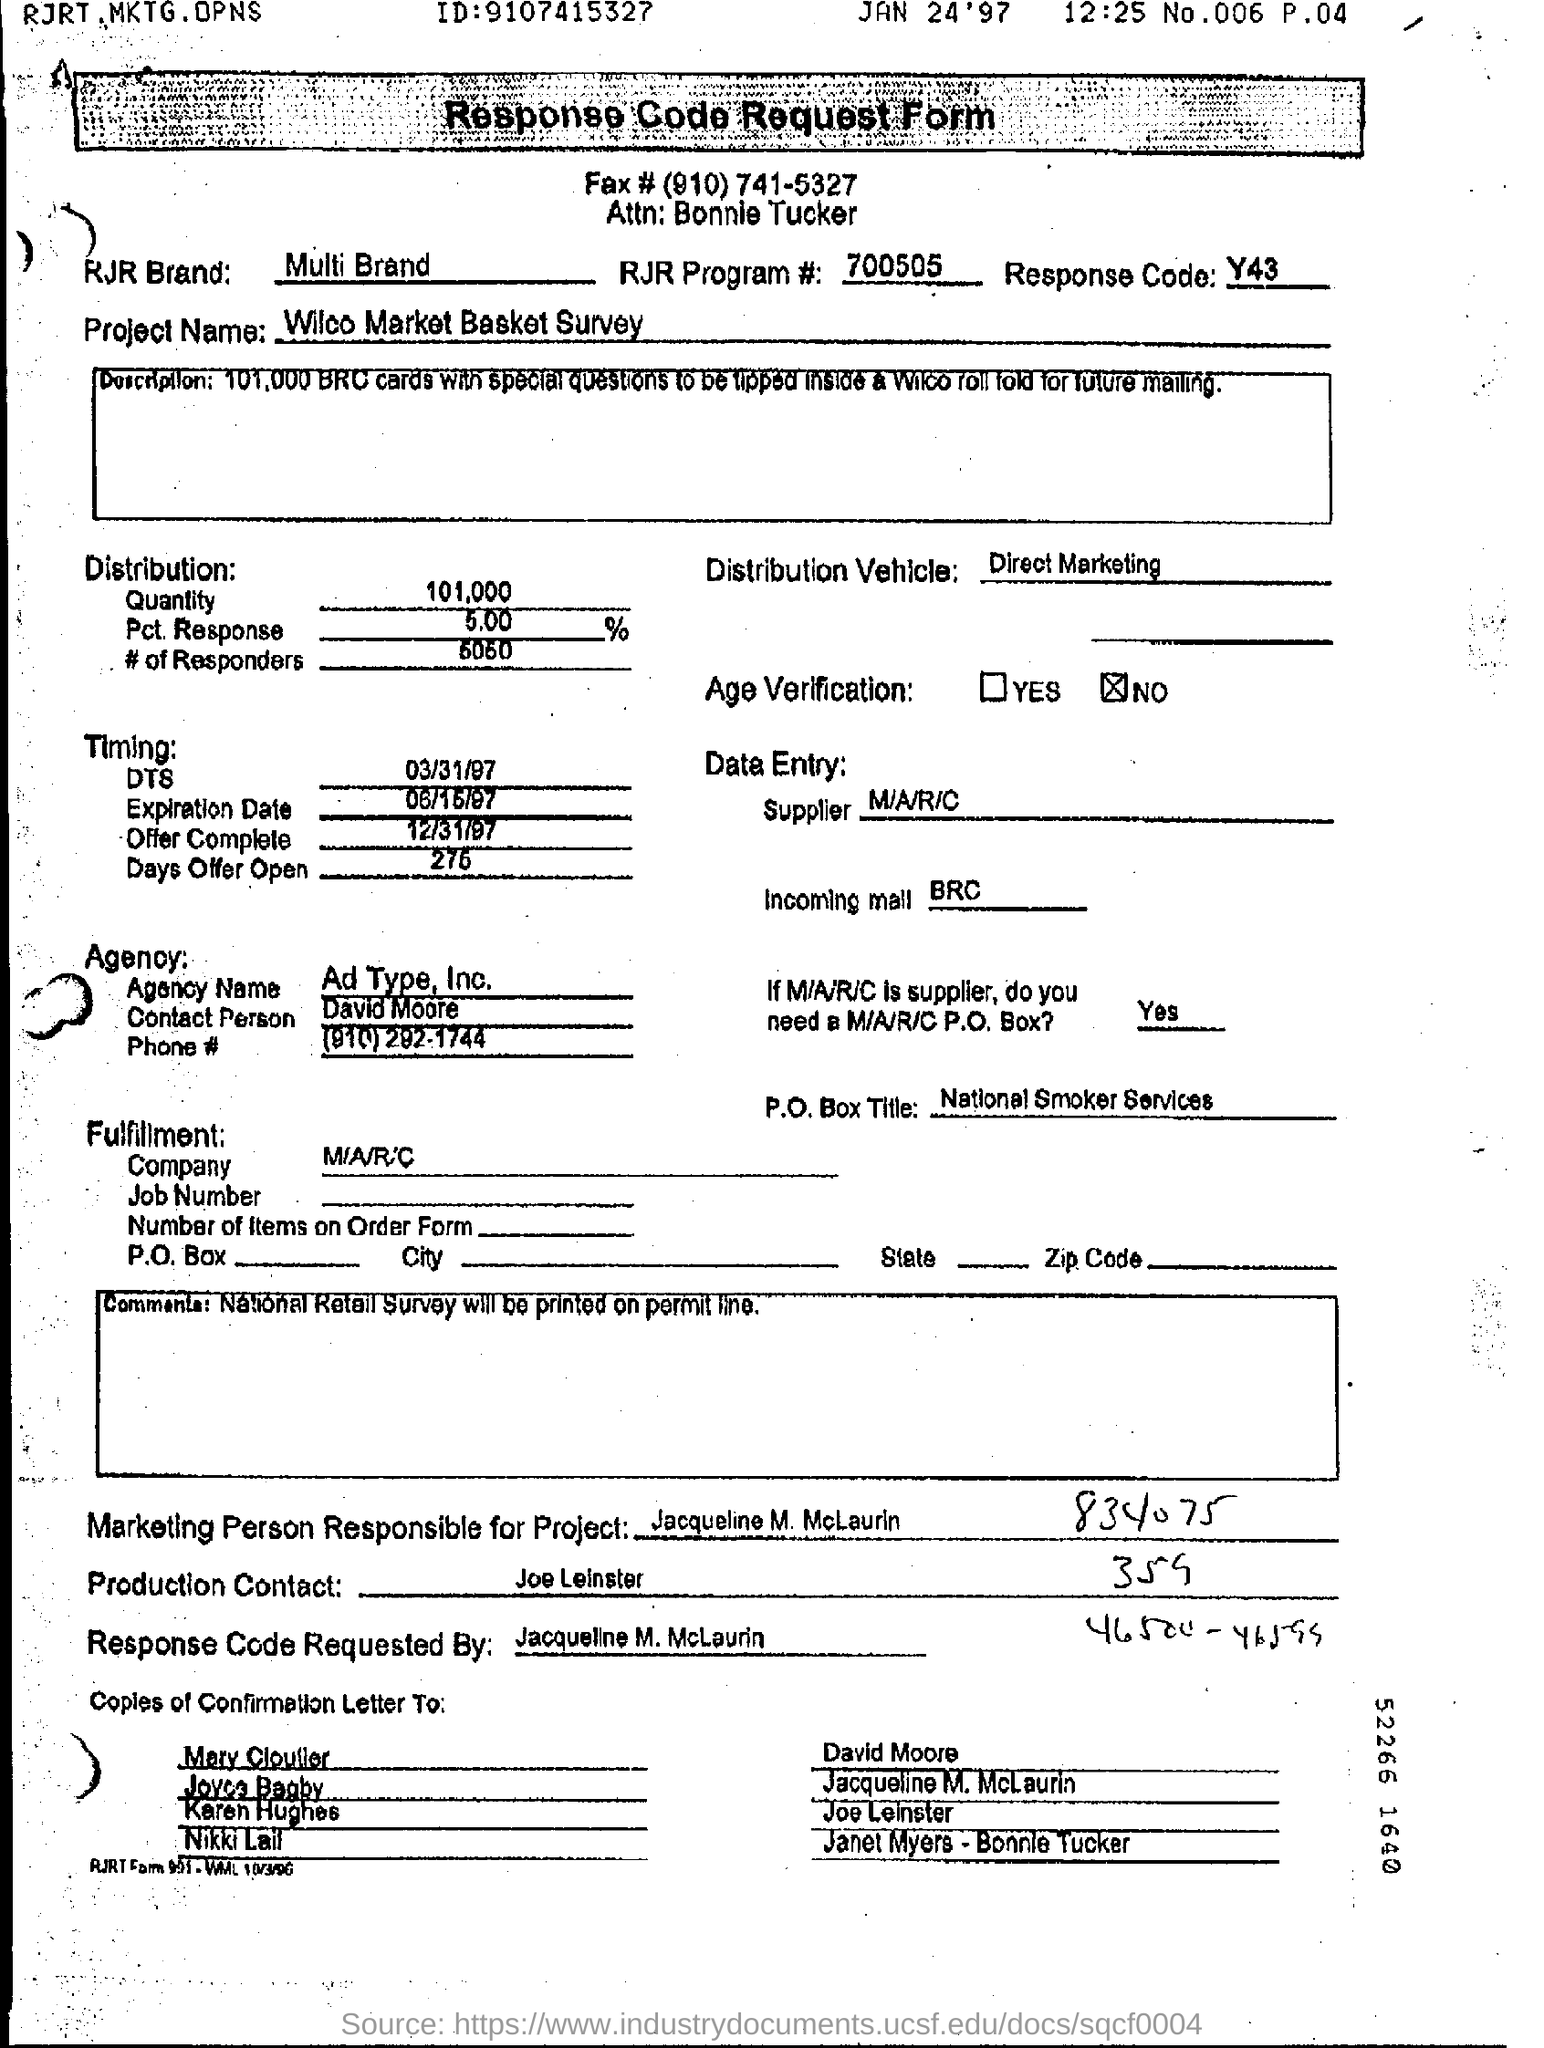Indicate a few pertinent items in this graphic. The agency name mentioned in the form is [Ad Type], and the account executive who is responsible for managing the account is [Inc.]. The response code is Y43. The contact person of the agency is David Moore. The individual responsible for the production of this document is Joe Leinster. 